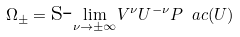Convert formula to latex. <formula><loc_0><loc_0><loc_500><loc_500>\Omega _ { \pm } = \text {s-} \underset { \nu \rightarrow \pm \infty } { \lim } V ^ { \nu } U ^ { - \nu } P _ { \ } a c ( U )</formula> 